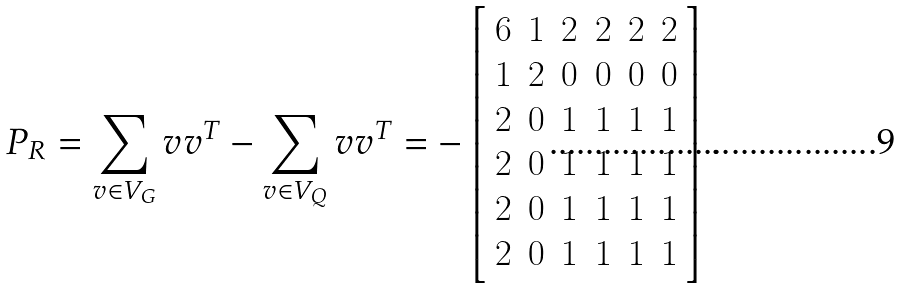<formula> <loc_0><loc_0><loc_500><loc_500>P _ { R } = \sum _ { v \in V _ { G } } v v ^ { T } - \sum _ { v \in V _ { Q } } v v ^ { T } = - \left [ \begin{array} { r r r r r r } 6 & 1 & 2 & 2 & 2 & 2 \\ 1 & 2 & 0 & 0 & 0 & 0 \\ 2 & 0 & 1 & 1 & 1 & 1 \\ 2 & 0 & 1 & 1 & 1 & 1 \\ 2 & 0 & 1 & 1 & 1 & 1 \\ 2 & 0 & 1 & 1 & 1 & 1 \end{array} \right ] .</formula> 